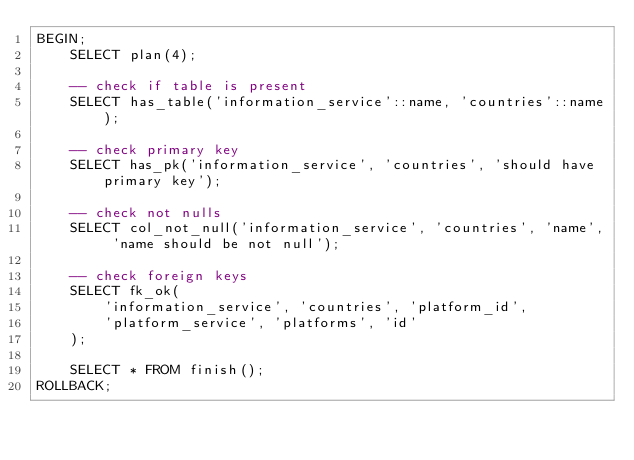<code> <loc_0><loc_0><loc_500><loc_500><_SQL_>BEGIN;
    SELECT plan(4);

    -- check if table is present
    SELECT has_table('information_service'::name, 'countries'::name);

    -- check primary key
    SELECT has_pk('information_service', 'countries', 'should have primary key');

    -- check not nulls
    SELECT col_not_null('information_service', 'countries', 'name', 'name should be not null');

    -- check foreign keys
    SELECT fk_ok(
        'information_service', 'countries', 'platform_id',
        'platform_service', 'platforms', 'id'
    );

    SELECT * FROM finish();
ROLLBACK;
</code> 